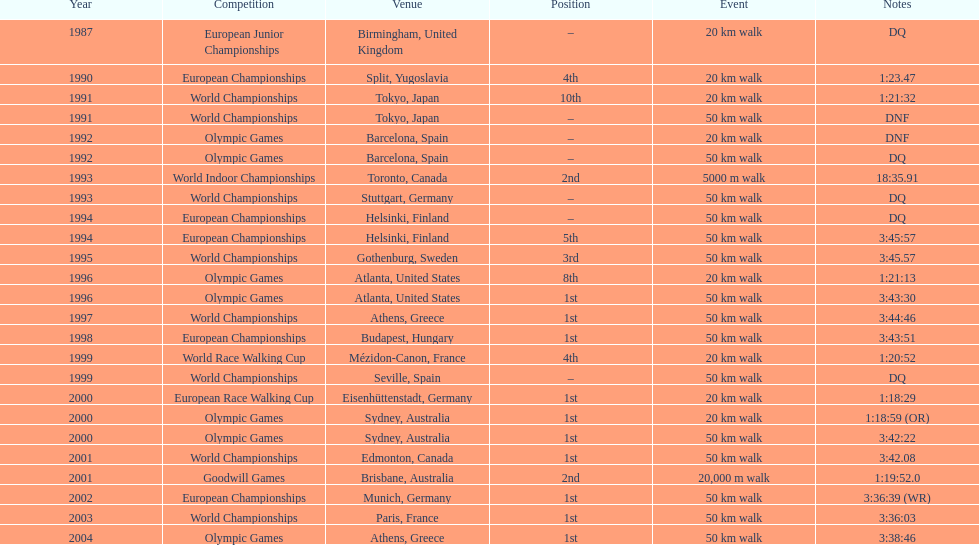What was the title of the contest that occurred prior to the 1996 olympic games? World Championships. Parse the table in full. {'header': ['Year', 'Competition', 'Venue', 'Position', 'Event', 'Notes'], 'rows': [['1987', 'European Junior Championships', 'Birmingham, United Kingdom', '–', '20\xa0km walk', 'DQ'], ['1990', 'European Championships', 'Split, Yugoslavia', '4th', '20\xa0km walk', '1:23.47'], ['1991', 'World Championships', 'Tokyo, Japan', '10th', '20\xa0km walk', '1:21:32'], ['1991', 'World Championships', 'Tokyo, Japan', '–', '50\xa0km walk', 'DNF'], ['1992', 'Olympic Games', 'Barcelona, Spain', '–', '20\xa0km walk', 'DNF'], ['1992', 'Olympic Games', 'Barcelona, Spain', '–', '50\xa0km walk', 'DQ'], ['1993', 'World Indoor Championships', 'Toronto, Canada', '2nd', '5000 m walk', '18:35.91'], ['1993', 'World Championships', 'Stuttgart, Germany', '–', '50\xa0km walk', 'DQ'], ['1994', 'European Championships', 'Helsinki, Finland', '–', '50\xa0km walk', 'DQ'], ['1994', 'European Championships', 'Helsinki, Finland', '5th', '50\xa0km walk', '3:45:57'], ['1995', 'World Championships', 'Gothenburg, Sweden', '3rd', '50\xa0km walk', '3:45.57'], ['1996', 'Olympic Games', 'Atlanta, United States', '8th', '20\xa0km walk', '1:21:13'], ['1996', 'Olympic Games', 'Atlanta, United States', '1st', '50\xa0km walk', '3:43:30'], ['1997', 'World Championships', 'Athens, Greece', '1st', '50\xa0km walk', '3:44:46'], ['1998', 'European Championships', 'Budapest, Hungary', '1st', '50\xa0km walk', '3:43:51'], ['1999', 'World Race Walking Cup', 'Mézidon-Canon, France', '4th', '20\xa0km walk', '1:20:52'], ['1999', 'World Championships', 'Seville, Spain', '–', '50\xa0km walk', 'DQ'], ['2000', 'European Race Walking Cup', 'Eisenhüttenstadt, Germany', '1st', '20\xa0km walk', '1:18:29'], ['2000', 'Olympic Games', 'Sydney, Australia', '1st', '20\xa0km walk', '1:18:59 (OR)'], ['2000', 'Olympic Games', 'Sydney, Australia', '1st', '50\xa0km walk', '3:42:22'], ['2001', 'World Championships', 'Edmonton, Canada', '1st', '50\xa0km walk', '3:42.08'], ['2001', 'Goodwill Games', 'Brisbane, Australia', '2nd', '20,000 m walk', '1:19:52.0'], ['2002', 'European Championships', 'Munich, Germany', '1st', '50\xa0km walk', '3:36:39 (WR)'], ['2003', 'World Championships', 'Paris, France', '1st', '50\xa0km walk', '3:36:03'], ['2004', 'Olympic Games', 'Athens, Greece', '1st', '50\xa0km walk', '3:38:46']]} 